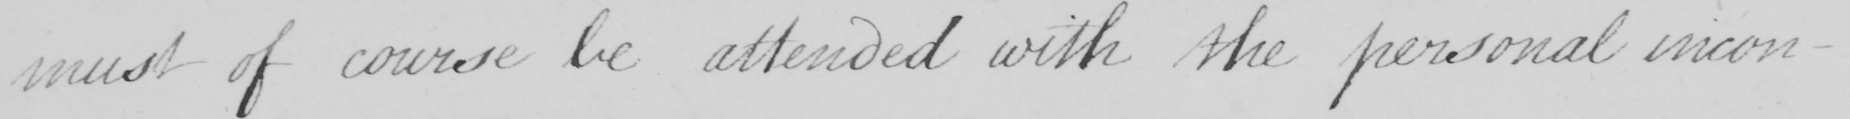What does this handwritten line say? must of course be attended with the personal inconven- 